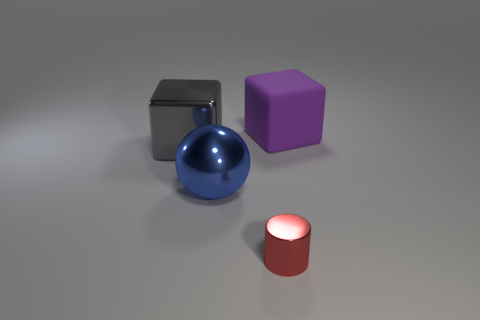Add 2 gray metallic cylinders. How many objects exist? 6 Subtract all balls. How many objects are left? 3 Subtract 1 red cylinders. How many objects are left? 3 Subtract all tiny cyan rubber cubes. Subtract all tiny red objects. How many objects are left? 3 Add 4 gray cubes. How many gray cubes are left? 5 Add 4 large gray shiny balls. How many large gray shiny balls exist? 4 